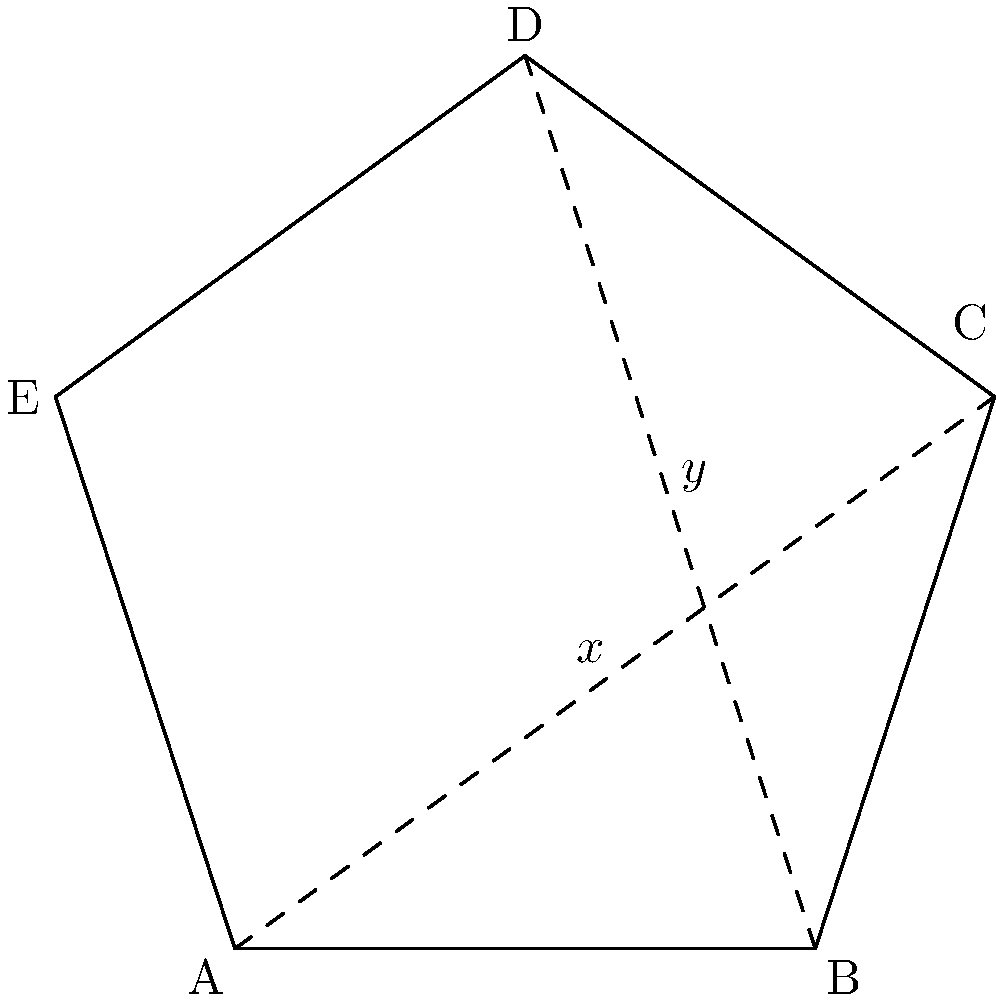In the pentagonal shape of the Globe Theatre's foundation, as shown in the diagram, what is the sum of angles $x$ and $y$? Let's approach this step-by-step:

1) In a regular pentagon, each interior angle measures $(540°/5) = 108°$.

2) The pentagon is divided into five triangles by drawing diagonals from one vertex to all non-adjacent vertices.

3) In the diagram, we see two of these triangles formed by the dashed lines.

4) In any triangle, the sum of all angles is 180°.

5) The angle at the center of the pentagon for each of these triangles is $(360°/5) = 72°$, as there are 5 equal triangles making up the full 360° at the center.

6) Therefore, in each triangle:
   $x + y + 72° = 180°$
   $x + y = 108°$

7) This matches our knowledge that each interior angle of a regular pentagon is 108°.

Thus, the sum of angles $x$ and $y$ is 108°.
Answer: $108°$ 